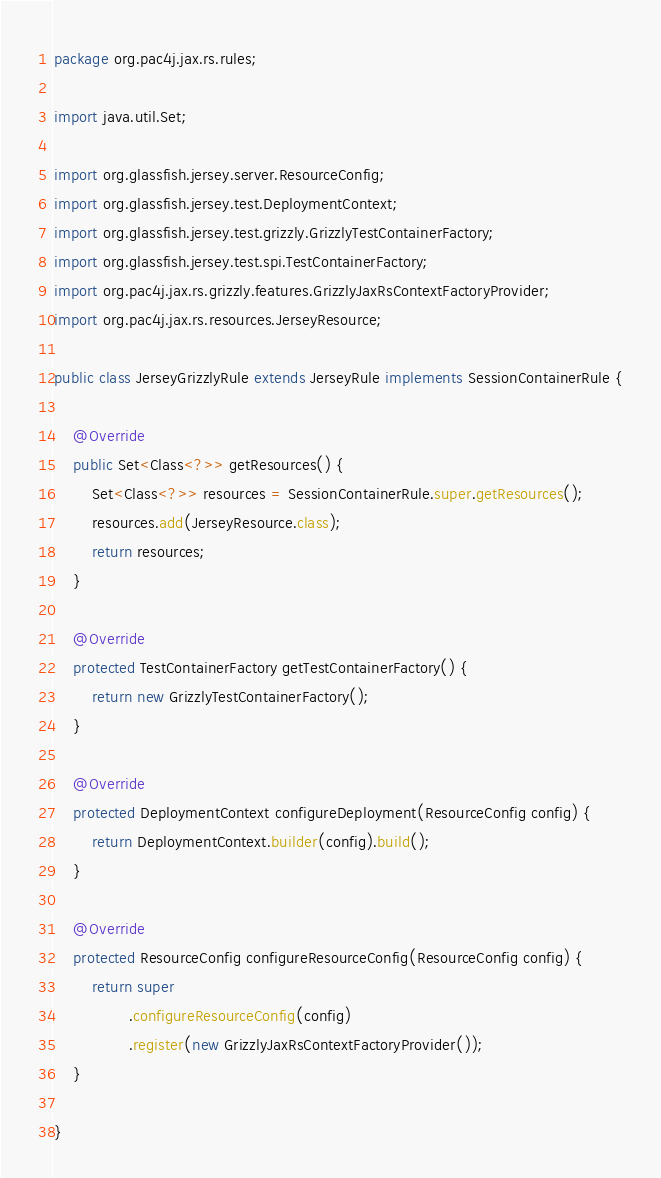Convert code to text. <code><loc_0><loc_0><loc_500><loc_500><_Java_>package org.pac4j.jax.rs.rules;

import java.util.Set;

import org.glassfish.jersey.server.ResourceConfig;
import org.glassfish.jersey.test.DeploymentContext;
import org.glassfish.jersey.test.grizzly.GrizzlyTestContainerFactory;
import org.glassfish.jersey.test.spi.TestContainerFactory;
import org.pac4j.jax.rs.grizzly.features.GrizzlyJaxRsContextFactoryProvider;
import org.pac4j.jax.rs.resources.JerseyResource;

public class JerseyGrizzlyRule extends JerseyRule implements SessionContainerRule {

    @Override
    public Set<Class<?>> getResources() {
        Set<Class<?>> resources = SessionContainerRule.super.getResources();
        resources.add(JerseyResource.class);
        return resources;
    }

    @Override
    protected TestContainerFactory getTestContainerFactory() {
        return new GrizzlyTestContainerFactory();
    }

    @Override
    protected DeploymentContext configureDeployment(ResourceConfig config) {
        return DeploymentContext.builder(config).build();
    }

    @Override
    protected ResourceConfig configureResourceConfig(ResourceConfig config) {
        return super
                .configureResourceConfig(config)
                .register(new GrizzlyJaxRsContextFactoryProvider());
    }

}
</code> 